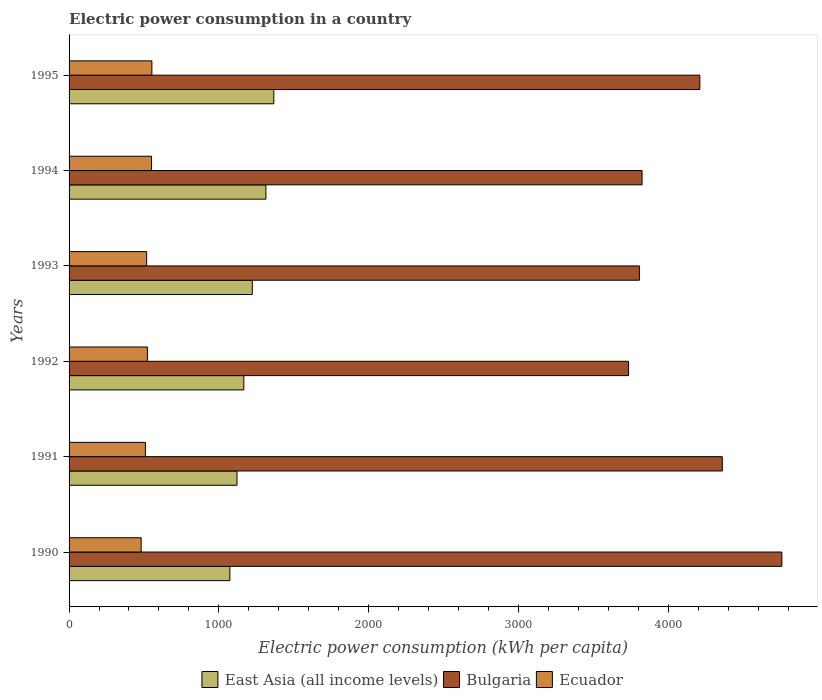How many groups of bars are there?
Give a very brief answer. 6. How many bars are there on the 1st tick from the top?
Your response must be concise. 3. How many bars are there on the 4th tick from the bottom?
Ensure brevity in your answer.  3. In how many cases, is the number of bars for a given year not equal to the number of legend labels?
Your answer should be compact. 0. What is the electric power consumption in in East Asia (all income levels) in 1992?
Offer a very short reply. 1166.77. Across all years, what is the maximum electric power consumption in in Bulgaria?
Your response must be concise. 4758.73. Across all years, what is the minimum electric power consumption in in East Asia (all income levels)?
Offer a very short reply. 1073.71. What is the total electric power consumption in in East Asia (all income levels) in the graph?
Provide a short and direct response. 7266.05. What is the difference between the electric power consumption in in East Asia (all income levels) in 1990 and that in 1993?
Offer a very short reply. -149.61. What is the difference between the electric power consumption in in Ecuador in 1990 and the electric power consumption in in Bulgaria in 1992?
Your response must be concise. -3254.22. What is the average electric power consumption in in East Asia (all income levels) per year?
Give a very brief answer. 1211.01. In the year 1993, what is the difference between the electric power consumption in in Bulgaria and electric power consumption in in Ecuador?
Offer a very short reply. 3289.85. What is the ratio of the electric power consumption in in Ecuador in 1992 to that in 1995?
Offer a terse response. 0.95. What is the difference between the highest and the second highest electric power consumption in in Ecuador?
Provide a succinct answer. 2.42. What is the difference between the highest and the lowest electric power consumption in in Ecuador?
Offer a terse response. 71.55. What does the 1st bar from the top in 1991 represents?
Give a very brief answer. Ecuador. What does the 3rd bar from the bottom in 1995 represents?
Ensure brevity in your answer.  Ecuador. How many bars are there?
Your response must be concise. 18. Are the values on the major ticks of X-axis written in scientific E-notation?
Keep it short and to the point. No. Does the graph contain grids?
Your response must be concise. No. Where does the legend appear in the graph?
Offer a very short reply. Bottom center. What is the title of the graph?
Provide a short and direct response. Electric power consumption in a country. Does "High income: nonOECD" appear as one of the legend labels in the graph?
Make the answer very short. No. What is the label or title of the X-axis?
Your answer should be very brief. Electric power consumption (kWh per capita). What is the label or title of the Y-axis?
Offer a very short reply. Years. What is the Electric power consumption (kWh per capita) in East Asia (all income levels) in 1990?
Make the answer very short. 1073.71. What is the Electric power consumption (kWh per capita) of Bulgaria in 1990?
Offer a very short reply. 4758.73. What is the Electric power consumption (kWh per capita) in Ecuador in 1990?
Your response must be concise. 481.3. What is the Electric power consumption (kWh per capita) in East Asia (all income levels) in 1991?
Offer a terse response. 1121.14. What is the Electric power consumption (kWh per capita) in Bulgaria in 1991?
Provide a short and direct response. 4361.14. What is the Electric power consumption (kWh per capita) of Ecuador in 1991?
Offer a very short reply. 509.51. What is the Electric power consumption (kWh per capita) of East Asia (all income levels) in 1992?
Your answer should be compact. 1166.77. What is the Electric power consumption (kWh per capita) in Bulgaria in 1992?
Ensure brevity in your answer.  3735.53. What is the Electric power consumption (kWh per capita) in Ecuador in 1992?
Your response must be concise. 522.99. What is the Electric power consumption (kWh per capita) in East Asia (all income levels) in 1993?
Your answer should be very brief. 1223.32. What is the Electric power consumption (kWh per capita) of Bulgaria in 1993?
Offer a terse response. 3807.7. What is the Electric power consumption (kWh per capita) in Ecuador in 1993?
Provide a short and direct response. 517.84. What is the Electric power consumption (kWh per capita) in East Asia (all income levels) in 1994?
Ensure brevity in your answer.  1314.13. What is the Electric power consumption (kWh per capita) of Bulgaria in 1994?
Keep it short and to the point. 3825.39. What is the Electric power consumption (kWh per capita) of Ecuador in 1994?
Make the answer very short. 550.44. What is the Electric power consumption (kWh per capita) in East Asia (all income levels) in 1995?
Provide a short and direct response. 1366.99. What is the Electric power consumption (kWh per capita) in Bulgaria in 1995?
Offer a terse response. 4211.13. What is the Electric power consumption (kWh per capita) in Ecuador in 1995?
Provide a short and direct response. 552.86. Across all years, what is the maximum Electric power consumption (kWh per capita) of East Asia (all income levels)?
Keep it short and to the point. 1366.99. Across all years, what is the maximum Electric power consumption (kWh per capita) of Bulgaria?
Offer a very short reply. 4758.73. Across all years, what is the maximum Electric power consumption (kWh per capita) in Ecuador?
Your answer should be very brief. 552.86. Across all years, what is the minimum Electric power consumption (kWh per capita) of East Asia (all income levels)?
Offer a terse response. 1073.71. Across all years, what is the minimum Electric power consumption (kWh per capita) in Bulgaria?
Provide a short and direct response. 3735.53. Across all years, what is the minimum Electric power consumption (kWh per capita) of Ecuador?
Give a very brief answer. 481.3. What is the total Electric power consumption (kWh per capita) in East Asia (all income levels) in the graph?
Your response must be concise. 7266.05. What is the total Electric power consumption (kWh per capita) of Bulgaria in the graph?
Offer a very short reply. 2.47e+04. What is the total Electric power consumption (kWh per capita) in Ecuador in the graph?
Offer a very short reply. 3134.95. What is the difference between the Electric power consumption (kWh per capita) of East Asia (all income levels) in 1990 and that in 1991?
Give a very brief answer. -47.43. What is the difference between the Electric power consumption (kWh per capita) of Bulgaria in 1990 and that in 1991?
Make the answer very short. 397.59. What is the difference between the Electric power consumption (kWh per capita) in Ecuador in 1990 and that in 1991?
Provide a short and direct response. -28.21. What is the difference between the Electric power consumption (kWh per capita) in East Asia (all income levels) in 1990 and that in 1992?
Your response must be concise. -93.06. What is the difference between the Electric power consumption (kWh per capita) of Bulgaria in 1990 and that in 1992?
Keep it short and to the point. 1023.21. What is the difference between the Electric power consumption (kWh per capita) of Ecuador in 1990 and that in 1992?
Provide a short and direct response. -41.69. What is the difference between the Electric power consumption (kWh per capita) of East Asia (all income levels) in 1990 and that in 1993?
Ensure brevity in your answer.  -149.61. What is the difference between the Electric power consumption (kWh per capita) of Bulgaria in 1990 and that in 1993?
Make the answer very short. 951.03. What is the difference between the Electric power consumption (kWh per capita) in Ecuador in 1990 and that in 1993?
Offer a very short reply. -36.54. What is the difference between the Electric power consumption (kWh per capita) in East Asia (all income levels) in 1990 and that in 1994?
Your answer should be very brief. -240.43. What is the difference between the Electric power consumption (kWh per capita) in Bulgaria in 1990 and that in 1994?
Provide a short and direct response. 933.35. What is the difference between the Electric power consumption (kWh per capita) in Ecuador in 1990 and that in 1994?
Keep it short and to the point. -69.14. What is the difference between the Electric power consumption (kWh per capita) in East Asia (all income levels) in 1990 and that in 1995?
Offer a very short reply. -293.28. What is the difference between the Electric power consumption (kWh per capita) in Bulgaria in 1990 and that in 1995?
Ensure brevity in your answer.  547.61. What is the difference between the Electric power consumption (kWh per capita) in Ecuador in 1990 and that in 1995?
Your response must be concise. -71.55. What is the difference between the Electric power consumption (kWh per capita) of East Asia (all income levels) in 1991 and that in 1992?
Your answer should be very brief. -45.63. What is the difference between the Electric power consumption (kWh per capita) in Bulgaria in 1991 and that in 1992?
Provide a short and direct response. 625.62. What is the difference between the Electric power consumption (kWh per capita) of Ecuador in 1991 and that in 1992?
Give a very brief answer. -13.48. What is the difference between the Electric power consumption (kWh per capita) of East Asia (all income levels) in 1991 and that in 1993?
Keep it short and to the point. -102.18. What is the difference between the Electric power consumption (kWh per capita) in Bulgaria in 1991 and that in 1993?
Ensure brevity in your answer.  553.45. What is the difference between the Electric power consumption (kWh per capita) in Ecuador in 1991 and that in 1993?
Give a very brief answer. -8.33. What is the difference between the Electric power consumption (kWh per capita) in East Asia (all income levels) in 1991 and that in 1994?
Your answer should be compact. -193. What is the difference between the Electric power consumption (kWh per capita) in Bulgaria in 1991 and that in 1994?
Ensure brevity in your answer.  535.76. What is the difference between the Electric power consumption (kWh per capita) of Ecuador in 1991 and that in 1994?
Offer a terse response. -40.93. What is the difference between the Electric power consumption (kWh per capita) of East Asia (all income levels) in 1991 and that in 1995?
Keep it short and to the point. -245.85. What is the difference between the Electric power consumption (kWh per capita) in Bulgaria in 1991 and that in 1995?
Provide a succinct answer. 150.02. What is the difference between the Electric power consumption (kWh per capita) of Ecuador in 1991 and that in 1995?
Your response must be concise. -43.34. What is the difference between the Electric power consumption (kWh per capita) in East Asia (all income levels) in 1992 and that in 1993?
Provide a succinct answer. -56.56. What is the difference between the Electric power consumption (kWh per capita) in Bulgaria in 1992 and that in 1993?
Make the answer very short. -72.17. What is the difference between the Electric power consumption (kWh per capita) in Ecuador in 1992 and that in 1993?
Give a very brief answer. 5.15. What is the difference between the Electric power consumption (kWh per capita) in East Asia (all income levels) in 1992 and that in 1994?
Your answer should be compact. -147.37. What is the difference between the Electric power consumption (kWh per capita) of Bulgaria in 1992 and that in 1994?
Your response must be concise. -89.86. What is the difference between the Electric power consumption (kWh per capita) of Ecuador in 1992 and that in 1994?
Offer a very short reply. -27.45. What is the difference between the Electric power consumption (kWh per capita) of East Asia (all income levels) in 1992 and that in 1995?
Make the answer very short. -200.22. What is the difference between the Electric power consumption (kWh per capita) of Bulgaria in 1992 and that in 1995?
Provide a succinct answer. -475.6. What is the difference between the Electric power consumption (kWh per capita) of Ecuador in 1992 and that in 1995?
Offer a very short reply. -29.86. What is the difference between the Electric power consumption (kWh per capita) in East Asia (all income levels) in 1993 and that in 1994?
Your response must be concise. -90.81. What is the difference between the Electric power consumption (kWh per capita) of Bulgaria in 1993 and that in 1994?
Your answer should be very brief. -17.69. What is the difference between the Electric power consumption (kWh per capita) of Ecuador in 1993 and that in 1994?
Your answer should be compact. -32.6. What is the difference between the Electric power consumption (kWh per capita) of East Asia (all income levels) in 1993 and that in 1995?
Offer a terse response. -143.67. What is the difference between the Electric power consumption (kWh per capita) in Bulgaria in 1993 and that in 1995?
Keep it short and to the point. -403.43. What is the difference between the Electric power consumption (kWh per capita) in Ecuador in 1993 and that in 1995?
Your answer should be compact. -35.01. What is the difference between the Electric power consumption (kWh per capita) in East Asia (all income levels) in 1994 and that in 1995?
Ensure brevity in your answer.  -52.85. What is the difference between the Electric power consumption (kWh per capita) in Bulgaria in 1994 and that in 1995?
Provide a short and direct response. -385.74. What is the difference between the Electric power consumption (kWh per capita) in Ecuador in 1994 and that in 1995?
Your answer should be very brief. -2.42. What is the difference between the Electric power consumption (kWh per capita) in East Asia (all income levels) in 1990 and the Electric power consumption (kWh per capita) in Bulgaria in 1991?
Provide a succinct answer. -3287.44. What is the difference between the Electric power consumption (kWh per capita) in East Asia (all income levels) in 1990 and the Electric power consumption (kWh per capita) in Ecuador in 1991?
Provide a short and direct response. 564.19. What is the difference between the Electric power consumption (kWh per capita) in Bulgaria in 1990 and the Electric power consumption (kWh per capita) in Ecuador in 1991?
Your answer should be very brief. 4249.22. What is the difference between the Electric power consumption (kWh per capita) in East Asia (all income levels) in 1990 and the Electric power consumption (kWh per capita) in Bulgaria in 1992?
Ensure brevity in your answer.  -2661.82. What is the difference between the Electric power consumption (kWh per capita) in East Asia (all income levels) in 1990 and the Electric power consumption (kWh per capita) in Ecuador in 1992?
Your answer should be very brief. 550.71. What is the difference between the Electric power consumption (kWh per capita) of Bulgaria in 1990 and the Electric power consumption (kWh per capita) of Ecuador in 1992?
Provide a short and direct response. 4235.74. What is the difference between the Electric power consumption (kWh per capita) in East Asia (all income levels) in 1990 and the Electric power consumption (kWh per capita) in Bulgaria in 1993?
Give a very brief answer. -2733.99. What is the difference between the Electric power consumption (kWh per capita) of East Asia (all income levels) in 1990 and the Electric power consumption (kWh per capita) of Ecuador in 1993?
Your answer should be compact. 555.86. What is the difference between the Electric power consumption (kWh per capita) in Bulgaria in 1990 and the Electric power consumption (kWh per capita) in Ecuador in 1993?
Ensure brevity in your answer.  4240.89. What is the difference between the Electric power consumption (kWh per capita) of East Asia (all income levels) in 1990 and the Electric power consumption (kWh per capita) of Bulgaria in 1994?
Provide a short and direct response. -2751.68. What is the difference between the Electric power consumption (kWh per capita) in East Asia (all income levels) in 1990 and the Electric power consumption (kWh per capita) in Ecuador in 1994?
Your answer should be very brief. 523.27. What is the difference between the Electric power consumption (kWh per capita) in Bulgaria in 1990 and the Electric power consumption (kWh per capita) in Ecuador in 1994?
Offer a terse response. 4208.29. What is the difference between the Electric power consumption (kWh per capita) in East Asia (all income levels) in 1990 and the Electric power consumption (kWh per capita) in Bulgaria in 1995?
Provide a short and direct response. -3137.42. What is the difference between the Electric power consumption (kWh per capita) of East Asia (all income levels) in 1990 and the Electric power consumption (kWh per capita) of Ecuador in 1995?
Your answer should be very brief. 520.85. What is the difference between the Electric power consumption (kWh per capita) of Bulgaria in 1990 and the Electric power consumption (kWh per capita) of Ecuador in 1995?
Provide a short and direct response. 4205.88. What is the difference between the Electric power consumption (kWh per capita) of East Asia (all income levels) in 1991 and the Electric power consumption (kWh per capita) of Bulgaria in 1992?
Your response must be concise. -2614.39. What is the difference between the Electric power consumption (kWh per capita) of East Asia (all income levels) in 1991 and the Electric power consumption (kWh per capita) of Ecuador in 1992?
Offer a very short reply. 598.14. What is the difference between the Electric power consumption (kWh per capita) of Bulgaria in 1991 and the Electric power consumption (kWh per capita) of Ecuador in 1992?
Give a very brief answer. 3838.15. What is the difference between the Electric power consumption (kWh per capita) of East Asia (all income levels) in 1991 and the Electric power consumption (kWh per capita) of Bulgaria in 1993?
Your answer should be very brief. -2686.56. What is the difference between the Electric power consumption (kWh per capita) of East Asia (all income levels) in 1991 and the Electric power consumption (kWh per capita) of Ecuador in 1993?
Your answer should be very brief. 603.3. What is the difference between the Electric power consumption (kWh per capita) in Bulgaria in 1991 and the Electric power consumption (kWh per capita) in Ecuador in 1993?
Offer a terse response. 3843.3. What is the difference between the Electric power consumption (kWh per capita) in East Asia (all income levels) in 1991 and the Electric power consumption (kWh per capita) in Bulgaria in 1994?
Provide a succinct answer. -2704.25. What is the difference between the Electric power consumption (kWh per capita) of East Asia (all income levels) in 1991 and the Electric power consumption (kWh per capita) of Ecuador in 1994?
Provide a succinct answer. 570.7. What is the difference between the Electric power consumption (kWh per capita) of Bulgaria in 1991 and the Electric power consumption (kWh per capita) of Ecuador in 1994?
Your answer should be compact. 3810.7. What is the difference between the Electric power consumption (kWh per capita) of East Asia (all income levels) in 1991 and the Electric power consumption (kWh per capita) of Bulgaria in 1995?
Your answer should be compact. -3089.99. What is the difference between the Electric power consumption (kWh per capita) in East Asia (all income levels) in 1991 and the Electric power consumption (kWh per capita) in Ecuador in 1995?
Your answer should be very brief. 568.28. What is the difference between the Electric power consumption (kWh per capita) of Bulgaria in 1991 and the Electric power consumption (kWh per capita) of Ecuador in 1995?
Provide a short and direct response. 3808.29. What is the difference between the Electric power consumption (kWh per capita) in East Asia (all income levels) in 1992 and the Electric power consumption (kWh per capita) in Bulgaria in 1993?
Give a very brief answer. -2640.93. What is the difference between the Electric power consumption (kWh per capita) in East Asia (all income levels) in 1992 and the Electric power consumption (kWh per capita) in Ecuador in 1993?
Your response must be concise. 648.92. What is the difference between the Electric power consumption (kWh per capita) of Bulgaria in 1992 and the Electric power consumption (kWh per capita) of Ecuador in 1993?
Provide a short and direct response. 3217.68. What is the difference between the Electric power consumption (kWh per capita) of East Asia (all income levels) in 1992 and the Electric power consumption (kWh per capita) of Bulgaria in 1994?
Your response must be concise. -2658.62. What is the difference between the Electric power consumption (kWh per capita) in East Asia (all income levels) in 1992 and the Electric power consumption (kWh per capita) in Ecuador in 1994?
Offer a very short reply. 616.32. What is the difference between the Electric power consumption (kWh per capita) of Bulgaria in 1992 and the Electric power consumption (kWh per capita) of Ecuador in 1994?
Your response must be concise. 3185.08. What is the difference between the Electric power consumption (kWh per capita) of East Asia (all income levels) in 1992 and the Electric power consumption (kWh per capita) of Bulgaria in 1995?
Your answer should be compact. -3044.36. What is the difference between the Electric power consumption (kWh per capita) of East Asia (all income levels) in 1992 and the Electric power consumption (kWh per capita) of Ecuador in 1995?
Offer a terse response. 613.91. What is the difference between the Electric power consumption (kWh per capita) of Bulgaria in 1992 and the Electric power consumption (kWh per capita) of Ecuador in 1995?
Keep it short and to the point. 3182.67. What is the difference between the Electric power consumption (kWh per capita) of East Asia (all income levels) in 1993 and the Electric power consumption (kWh per capita) of Bulgaria in 1994?
Keep it short and to the point. -2602.07. What is the difference between the Electric power consumption (kWh per capita) of East Asia (all income levels) in 1993 and the Electric power consumption (kWh per capita) of Ecuador in 1994?
Give a very brief answer. 672.88. What is the difference between the Electric power consumption (kWh per capita) in Bulgaria in 1993 and the Electric power consumption (kWh per capita) in Ecuador in 1994?
Make the answer very short. 3257.26. What is the difference between the Electric power consumption (kWh per capita) of East Asia (all income levels) in 1993 and the Electric power consumption (kWh per capita) of Bulgaria in 1995?
Ensure brevity in your answer.  -2987.8. What is the difference between the Electric power consumption (kWh per capita) in East Asia (all income levels) in 1993 and the Electric power consumption (kWh per capita) in Ecuador in 1995?
Your answer should be compact. 670.46. What is the difference between the Electric power consumption (kWh per capita) in Bulgaria in 1993 and the Electric power consumption (kWh per capita) in Ecuador in 1995?
Your answer should be very brief. 3254.84. What is the difference between the Electric power consumption (kWh per capita) in East Asia (all income levels) in 1994 and the Electric power consumption (kWh per capita) in Bulgaria in 1995?
Keep it short and to the point. -2896.99. What is the difference between the Electric power consumption (kWh per capita) in East Asia (all income levels) in 1994 and the Electric power consumption (kWh per capita) in Ecuador in 1995?
Offer a terse response. 761.28. What is the difference between the Electric power consumption (kWh per capita) of Bulgaria in 1994 and the Electric power consumption (kWh per capita) of Ecuador in 1995?
Your answer should be very brief. 3272.53. What is the average Electric power consumption (kWh per capita) in East Asia (all income levels) per year?
Ensure brevity in your answer.  1211.01. What is the average Electric power consumption (kWh per capita) of Bulgaria per year?
Your answer should be very brief. 4116.6. What is the average Electric power consumption (kWh per capita) in Ecuador per year?
Provide a short and direct response. 522.49. In the year 1990, what is the difference between the Electric power consumption (kWh per capita) of East Asia (all income levels) and Electric power consumption (kWh per capita) of Bulgaria?
Offer a terse response. -3685.03. In the year 1990, what is the difference between the Electric power consumption (kWh per capita) in East Asia (all income levels) and Electric power consumption (kWh per capita) in Ecuador?
Your response must be concise. 592.4. In the year 1990, what is the difference between the Electric power consumption (kWh per capita) in Bulgaria and Electric power consumption (kWh per capita) in Ecuador?
Provide a succinct answer. 4277.43. In the year 1991, what is the difference between the Electric power consumption (kWh per capita) of East Asia (all income levels) and Electric power consumption (kWh per capita) of Bulgaria?
Your answer should be very brief. -3240.01. In the year 1991, what is the difference between the Electric power consumption (kWh per capita) of East Asia (all income levels) and Electric power consumption (kWh per capita) of Ecuador?
Provide a succinct answer. 611.63. In the year 1991, what is the difference between the Electric power consumption (kWh per capita) in Bulgaria and Electric power consumption (kWh per capita) in Ecuador?
Keep it short and to the point. 3851.63. In the year 1992, what is the difference between the Electric power consumption (kWh per capita) in East Asia (all income levels) and Electric power consumption (kWh per capita) in Bulgaria?
Provide a short and direct response. -2568.76. In the year 1992, what is the difference between the Electric power consumption (kWh per capita) of East Asia (all income levels) and Electric power consumption (kWh per capita) of Ecuador?
Make the answer very short. 643.77. In the year 1992, what is the difference between the Electric power consumption (kWh per capita) of Bulgaria and Electric power consumption (kWh per capita) of Ecuador?
Make the answer very short. 3212.53. In the year 1993, what is the difference between the Electric power consumption (kWh per capita) of East Asia (all income levels) and Electric power consumption (kWh per capita) of Bulgaria?
Your answer should be very brief. -2584.38. In the year 1993, what is the difference between the Electric power consumption (kWh per capita) in East Asia (all income levels) and Electric power consumption (kWh per capita) in Ecuador?
Provide a succinct answer. 705.48. In the year 1993, what is the difference between the Electric power consumption (kWh per capita) of Bulgaria and Electric power consumption (kWh per capita) of Ecuador?
Provide a short and direct response. 3289.85. In the year 1994, what is the difference between the Electric power consumption (kWh per capita) in East Asia (all income levels) and Electric power consumption (kWh per capita) in Bulgaria?
Provide a short and direct response. -2511.25. In the year 1994, what is the difference between the Electric power consumption (kWh per capita) in East Asia (all income levels) and Electric power consumption (kWh per capita) in Ecuador?
Ensure brevity in your answer.  763.69. In the year 1994, what is the difference between the Electric power consumption (kWh per capita) of Bulgaria and Electric power consumption (kWh per capita) of Ecuador?
Your response must be concise. 3274.95. In the year 1995, what is the difference between the Electric power consumption (kWh per capita) in East Asia (all income levels) and Electric power consumption (kWh per capita) in Bulgaria?
Offer a terse response. -2844.14. In the year 1995, what is the difference between the Electric power consumption (kWh per capita) in East Asia (all income levels) and Electric power consumption (kWh per capita) in Ecuador?
Provide a succinct answer. 814.13. In the year 1995, what is the difference between the Electric power consumption (kWh per capita) of Bulgaria and Electric power consumption (kWh per capita) of Ecuador?
Offer a very short reply. 3658.27. What is the ratio of the Electric power consumption (kWh per capita) of East Asia (all income levels) in 1990 to that in 1991?
Your response must be concise. 0.96. What is the ratio of the Electric power consumption (kWh per capita) in Bulgaria in 1990 to that in 1991?
Your answer should be compact. 1.09. What is the ratio of the Electric power consumption (kWh per capita) in Ecuador in 1990 to that in 1991?
Provide a succinct answer. 0.94. What is the ratio of the Electric power consumption (kWh per capita) in East Asia (all income levels) in 1990 to that in 1992?
Give a very brief answer. 0.92. What is the ratio of the Electric power consumption (kWh per capita) in Bulgaria in 1990 to that in 1992?
Your answer should be very brief. 1.27. What is the ratio of the Electric power consumption (kWh per capita) of Ecuador in 1990 to that in 1992?
Keep it short and to the point. 0.92. What is the ratio of the Electric power consumption (kWh per capita) in East Asia (all income levels) in 1990 to that in 1993?
Provide a short and direct response. 0.88. What is the ratio of the Electric power consumption (kWh per capita) in Bulgaria in 1990 to that in 1993?
Provide a short and direct response. 1.25. What is the ratio of the Electric power consumption (kWh per capita) in Ecuador in 1990 to that in 1993?
Your answer should be compact. 0.93. What is the ratio of the Electric power consumption (kWh per capita) in East Asia (all income levels) in 1990 to that in 1994?
Give a very brief answer. 0.82. What is the ratio of the Electric power consumption (kWh per capita) in Bulgaria in 1990 to that in 1994?
Give a very brief answer. 1.24. What is the ratio of the Electric power consumption (kWh per capita) in Ecuador in 1990 to that in 1994?
Keep it short and to the point. 0.87. What is the ratio of the Electric power consumption (kWh per capita) in East Asia (all income levels) in 1990 to that in 1995?
Your answer should be very brief. 0.79. What is the ratio of the Electric power consumption (kWh per capita) of Bulgaria in 1990 to that in 1995?
Offer a very short reply. 1.13. What is the ratio of the Electric power consumption (kWh per capita) in Ecuador in 1990 to that in 1995?
Offer a very short reply. 0.87. What is the ratio of the Electric power consumption (kWh per capita) in East Asia (all income levels) in 1991 to that in 1992?
Your response must be concise. 0.96. What is the ratio of the Electric power consumption (kWh per capita) in Bulgaria in 1991 to that in 1992?
Offer a very short reply. 1.17. What is the ratio of the Electric power consumption (kWh per capita) in Ecuador in 1991 to that in 1992?
Offer a terse response. 0.97. What is the ratio of the Electric power consumption (kWh per capita) of East Asia (all income levels) in 1991 to that in 1993?
Provide a short and direct response. 0.92. What is the ratio of the Electric power consumption (kWh per capita) in Bulgaria in 1991 to that in 1993?
Offer a very short reply. 1.15. What is the ratio of the Electric power consumption (kWh per capita) in Ecuador in 1991 to that in 1993?
Your answer should be very brief. 0.98. What is the ratio of the Electric power consumption (kWh per capita) of East Asia (all income levels) in 1991 to that in 1994?
Make the answer very short. 0.85. What is the ratio of the Electric power consumption (kWh per capita) of Bulgaria in 1991 to that in 1994?
Provide a succinct answer. 1.14. What is the ratio of the Electric power consumption (kWh per capita) of Ecuador in 1991 to that in 1994?
Offer a very short reply. 0.93. What is the ratio of the Electric power consumption (kWh per capita) in East Asia (all income levels) in 1991 to that in 1995?
Make the answer very short. 0.82. What is the ratio of the Electric power consumption (kWh per capita) in Bulgaria in 1991 to that in 1995?
Ensure brevity in your answer.  1.04. What is the ratio of the Electric power consumption (kWh per capita) of Ecuador in 1991 to that in 1995?
Your answer should be compact. 0.92. What is the ratio of the Electric power consumption (kWh per capita) of East Asia (all income levels) in 1992 to that in 1993?
Provide a short and direct response. 0.95. What is the ratio of the Electric power consumption (kWh per capita) of Ecuador in 1992 to that in 1993?
Your answer should be compact. 1.01. What is the ratio of the Electric power consumption (kWh per capita) of East Asia (all income levels) in 1992 to that in 1994?
Make the answer very short. 0.89. What is the ratio of the Electric power consumption (kWh per capita) in Bulgaria in 1992 to that in 1994?
Your response must be concise. 0.98. What is the ratio of the Electric power consumption (kWh per capita) in Ecuador in 1992 to that in 1994?
Give a very brief answer. 0.95. What is the ratio of the Electric power consumption (kWh per capita) in East Asia (all income levels) in 1992 to that in 1995?
Make the answer very short. 0.85. What is the ratio of the Electric power consumption (kWh per capita) in Bulgaria in 1992 to that in 1995?
Provide a succinct answer. 0.89. What is the ratio of the Electric power consumption (kWh per capita) in Ecuador in 1992 to that in 1995?
Offer a very short reply. 0.95. What is the ratio of the Electric power consumption (kWh per capita) of East Asia (all income levels) in 1993 to that in 1994?
Offer a very short reply. 0.93. What is the ratio of the Electric power consumption (kWh per capita) in Bulgaria in 1993 to that in 1994?
Make the answer very short. 1. What is the ratio of the Electric power consumption (kWh per capita) in Ecuador in 1993 to that in 1994?
Provide a succinct answer. 0.94. What is the ratio of the Electric power consumption (kWh per capita) in East Asia (all income levels) in 1993 to that in 1995?
Your answer should be very brief. 0.89. What is the ratio of the Electric power consumption (kWh per capita) of Bulgaria in 1993 to that in 1995?
Keep it short and to the point. 0.9. What is the ratio of the Electric power consumption (kWh per capita) of Ecuador in 1993 to that in 1995?
Your response must be concise. 0.94. What is the ratio of the Electric power consumption (kWh per capita) of East Asia (all income levels) in 1994 to that in 1995?
Your response must be concise. 0.96. What is the ratio of the Electric power consumption (kWh per capita) in Bulgaria in 1994 to that in 1995?
Ensure brevity in your answer.  0.91. What is the ratio of the Electric power consumption (kWh per capita) in Ecuador in 1994 to that in 1995?
Make the answer very short. 1. What is the difference between the highest and the second highest Electric power consumption (kWh per capita) in East Asia (all income levels)?
Provide a succinct answer. 52.85. What is the difference between the highest and the second highest Electric power consumption (kWh per capita) of Bulgaria?
Your response must be concise. 397.59. What is the difference between the highest and the second highest Electric power consumption (kWh per capita) in Ecuador?
Your answer should be very brief. 2.42. What is the difference between the highest and the lowest Electric power consumption (kWh per capita) in East Asia (all income levels)?
Your response must be concise. 293.28. What is the difference between the highest and the lowest Electric power consumption (kWh per capita) in Bulgaria?
Provide a short and direct response. 1023.21. What is the difference between the highest and the lowest Electric power consumption (kWh per capita) of Ecuador?
Give a very brief answer. 71.55. 